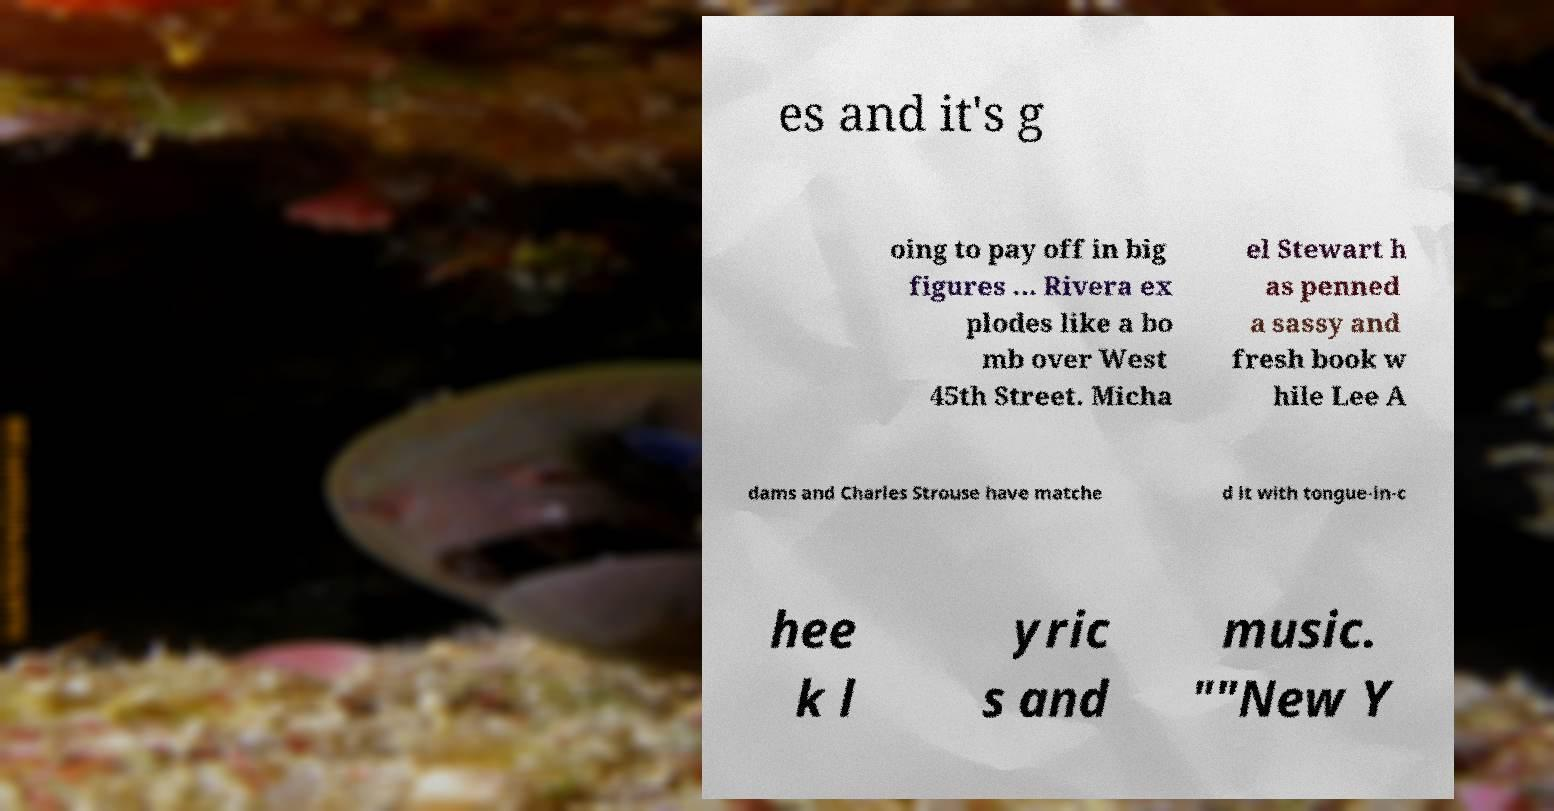Could you assist in decoding the text presented in this image and type it out clearly? es and it's g oing to pay off in big figures ... Rivera ex plodes like a bo mb over West 45th Street. Micha el Stewart h as penned a sassy and fresh book w hile Lee A dams and Charles Strouse have matche d it with tongue-in-c hee k l yric s and music. ""New Y 